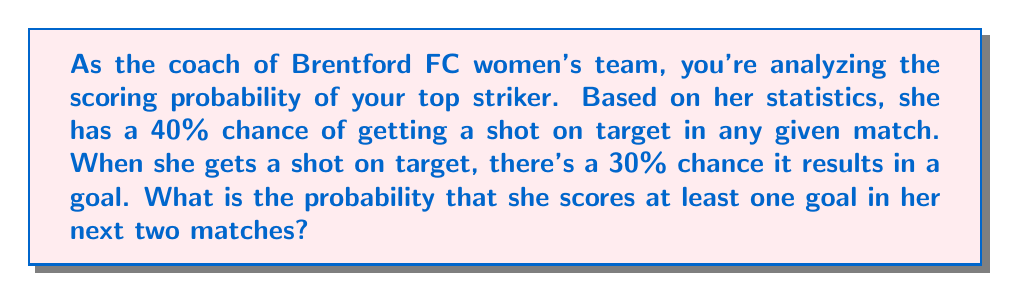Give your solution to this math problem. Let's approach this step-by-step:

1) First, let's calculate the probability of scoring in a single match:
   
   P(scoring) = P(shot on target) × P(goal | shot on target)
   $$ P(\text{scoring}) = 0.40 \times 0.30 = 0.12 $$

2) Now, we need to find the probability of scoring at least one goal in two matches. It's easier to calculate the probability of not scoring in both matches and then subtract from 1:

   P(at least one goal in two matches) = 1 - P(no goals in two matches)

3) The probability of not scoring in a single match is:
   $$ P(\text{not scoring}) = 1 - 0.12 = 0.88 $$

4) For two independent matches, the probability of not scoring in both is:
   $$ P(\text{no goals in two matches}) = 0.88 \times 0.88 = 0.7744 $$

5) Therefore, the probability of scoring at least one goal in two matches is:
   $$ P(\text{at least one goal in two matches}) = 1 - 0.7744 = 0.2256 $$

6) Converting to a percentage:
   $$ 0.2256 \times 100\% = 22.56\% $$
Answer: The probability that the striker scores at least one goal in her next two matches is approximately 22.56%. 